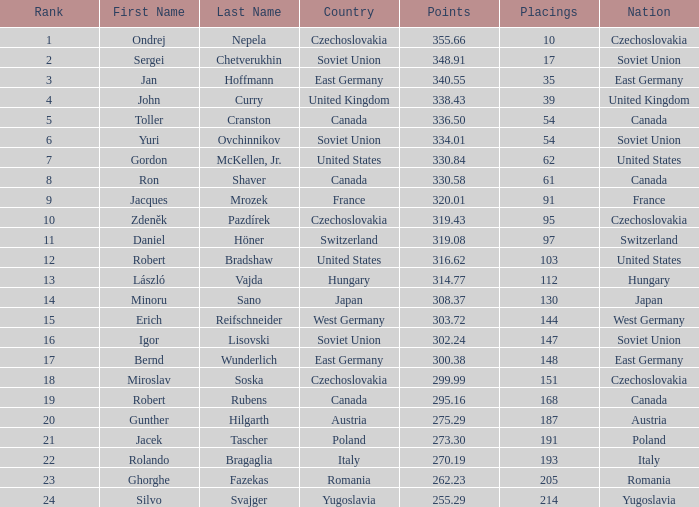For a nation in west germany, which spots have a point total exceeding 303.72? None. 